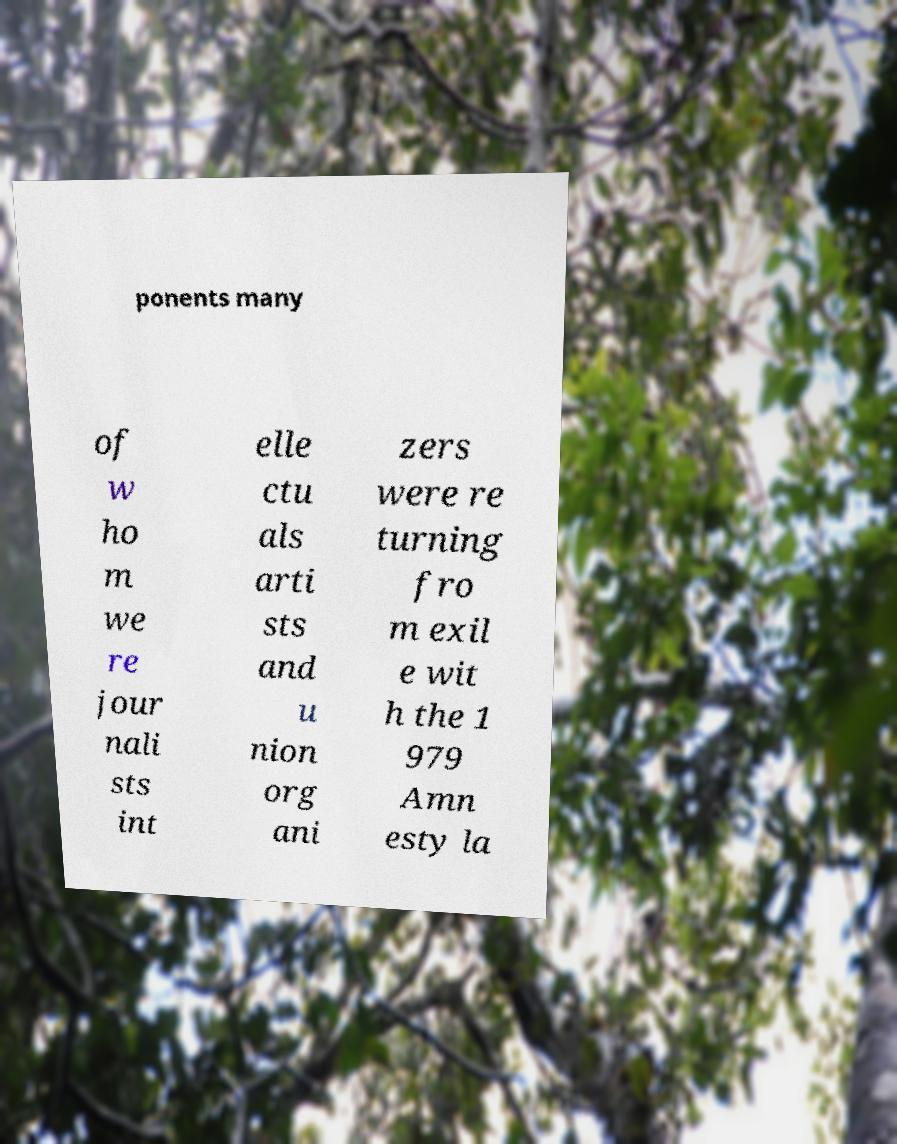Could you assist in decoding the text presented in this image and type it out clearly? ponents many of w ho m we re jour nali sts int elle ctu als arti sts and u nion org ani zers were re turning fro m exil e wit h the 1 979 Amn esty la 